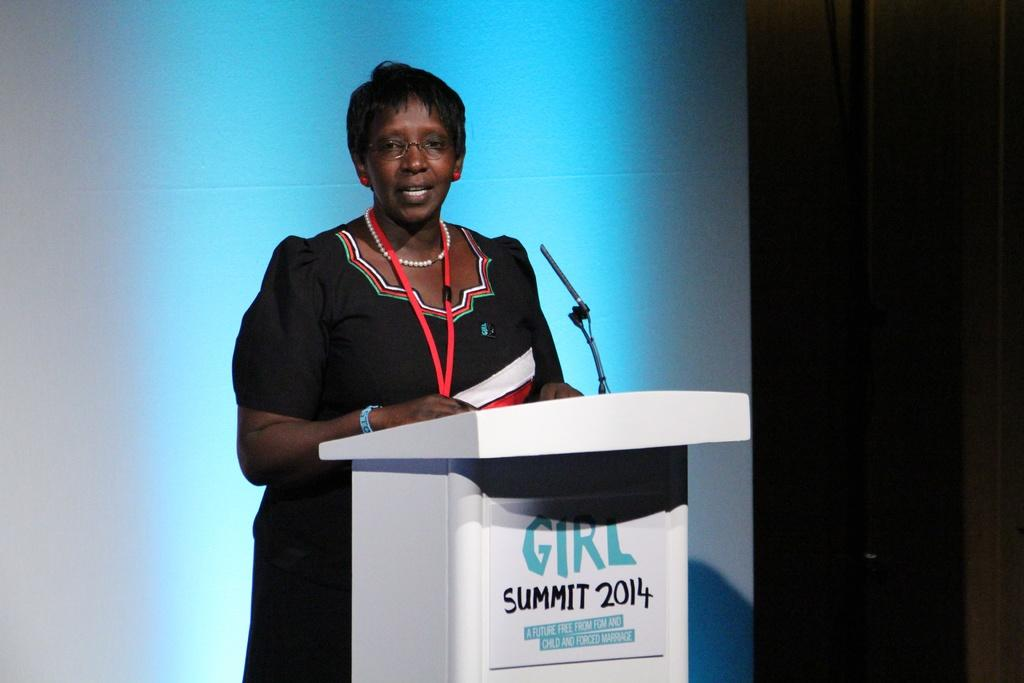<image>
Summarize the visual content of the image. A black lady speaking at a podium for Girl Summit 2014. 